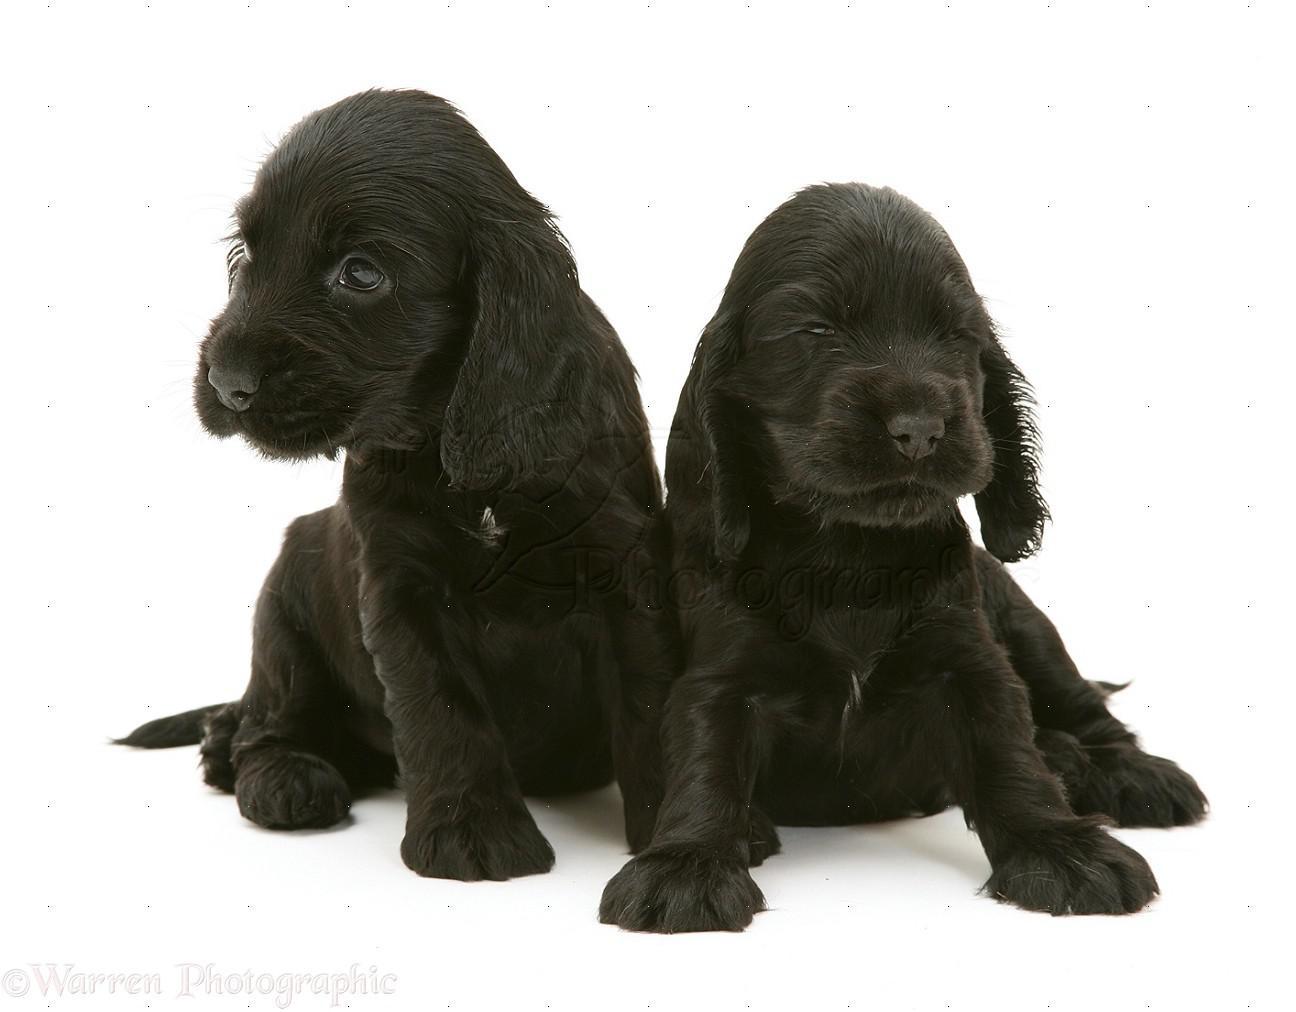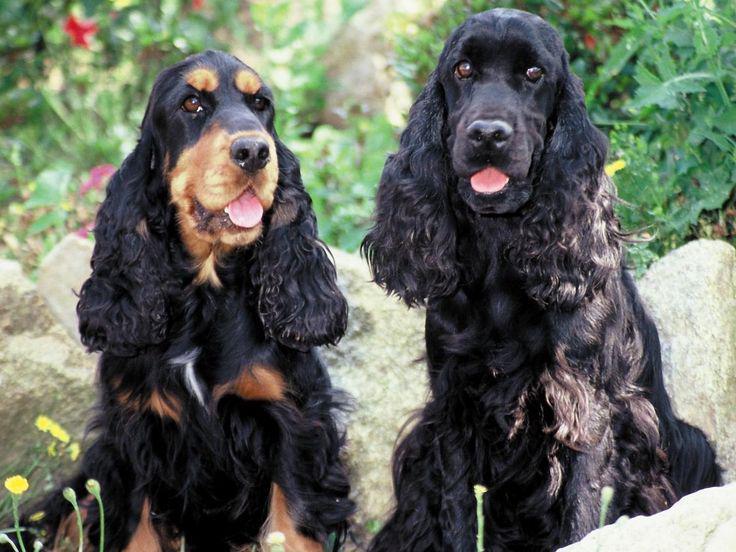The first image is the image on the left, the second image is the image on the right. Analyze the images presented: Is the assertion "Two puppies sit together in the image on the left." valid? Answer yes or no. Yes. The first image is the image on the left, the second image is the image on the right. Evaluate the accuracy of this statement regarding the images: "The left image contains two dark dogs.". Is it true? Answer yes or no. Yes. 